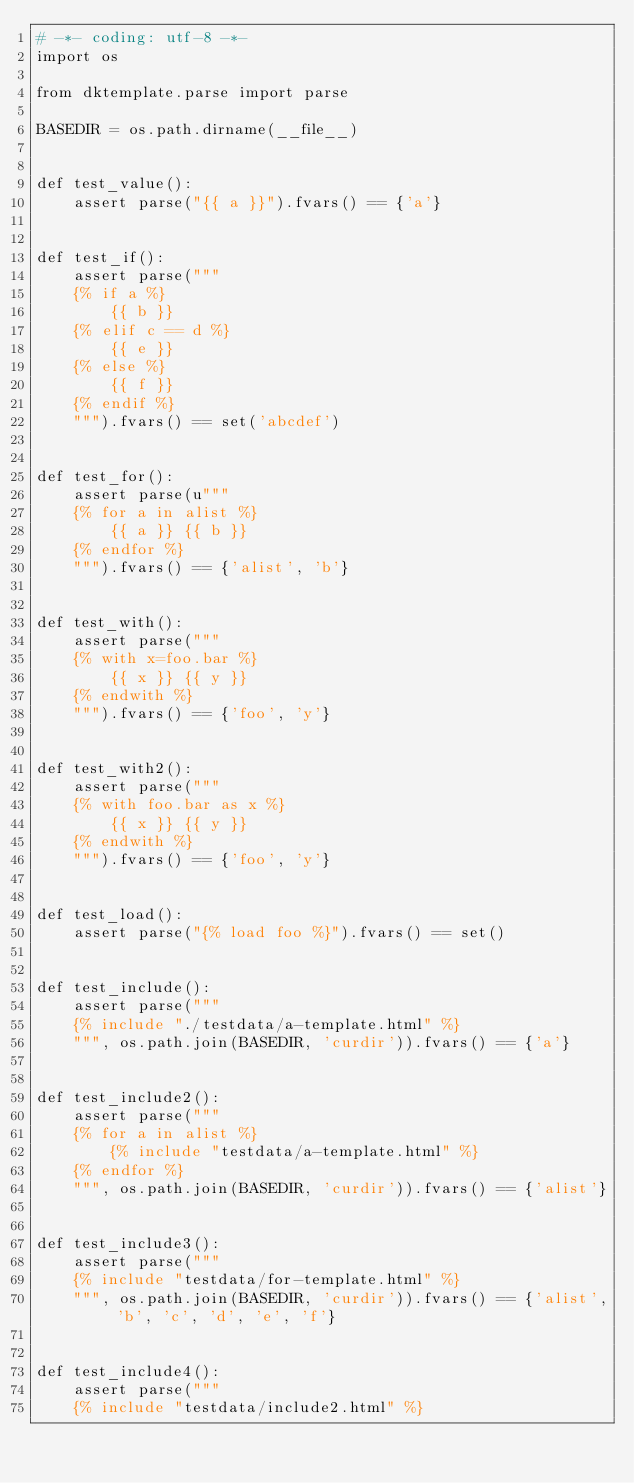Convert code to text. <code><loc_0><loc_0><loc_500><loc_500><_Python_># -*- coding: utf-8 -*-
import os

from dktemplate.parse import parse

BASEDIR = os.path.dirname(__file__)


def test_value():
    assert parse("{{ a }}").fvars() == {'a'}


def test_if():
    assert parse("""
    {% if a %}
        {{ b }}
    {% elif c == d %}
        {{ e }}
    {% else %}
        {{ f }}
    {% endif %}
    """).fvars() == set('abcdef')


def test_for():
    assert parse(u"""
    {% for a in alist %}
        {{ a }} {{ b }}
    {% endfor %}
    """).fvars() == {'alist', 'b'}


def test_with():
    assert parse("""
    {% with x=foo.bar %}
        {{ x }} {{ y }}
    {% endwith %}
    """).fvars() == {'foo', 'y'}


def test_with2():
    assert parse("""
    {% with foo.bar as x %}
        {{ x }} {{ y }}
    {% endwith %}
    """).fvars() == {'foo', 'y'}


def test_load():
    assert parse("{% load foo %}").fvars() == set()


def test_include():
    assert parse("""
    {% include "./testdata/a-template.html" %}
    """, os.path.join(BASEDIR, 'curdir')).fvars() == {'a'}


def test_include2():
    assert parse("""
    {% for a in alist %}
        {% include "testdata/a-template.html" %}
    {% endfor %}
    """, os.path.join(BASEDIR, 'curdir')).fvars() == {'alist'}


def test_include3():
    assert parse("""
    {% include "testdata/for-template.html" %}
    """, os.path.join(BASEDIR, 'curdir')).fvars() == {'alist', 'b', 'c', 'd', 'e', 'f'}


def test_include4():
    assert parse("""
    {% include "testdata/include2.html" %}</code> 